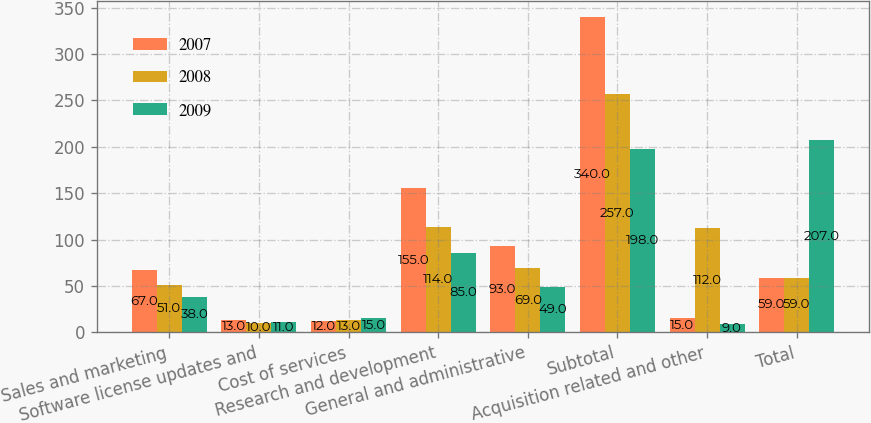Convert chart to OTSL. <chart><loc_0><loc_0><loc_500><loc_500><stacked_bar_chart><ecel><fcel>Sales and marketing<fcel>Software license updates and<fcel>Cost of services<fcel>Research and development<fcel>General and administrative<fcel>Subtotal<fcel>Acquisition related and other<fcel>Total<nl><fcel>2007<fcel>67<fcel>13<fcel>12<fcel>155<fcel>93<fcel>340<fcel>15<fcel>59<nl><fcel>2008<fcel>51<fcel>10<fcel>13<fcel>114<fcel>69<fcel>257<fcel>112<fcel>59<nl><fcel>2009<fcel>38<fcel>11<fcel>15<fcel>85<fcel>49<fcel>198<fcel>9<fcel>207<nl></chart> 